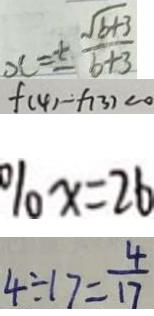<formula> <loc_0><loc_0><loc_500><loc_500>x = \pm \frac { \sqrt { b + 3 } } { b + 3 } 
 f ( 4 ) - f ( 3 ) < 0 
 \% x = 2 6 
 4 \div 1 7 = \frac { 4 } { 1 7 }</formula> 